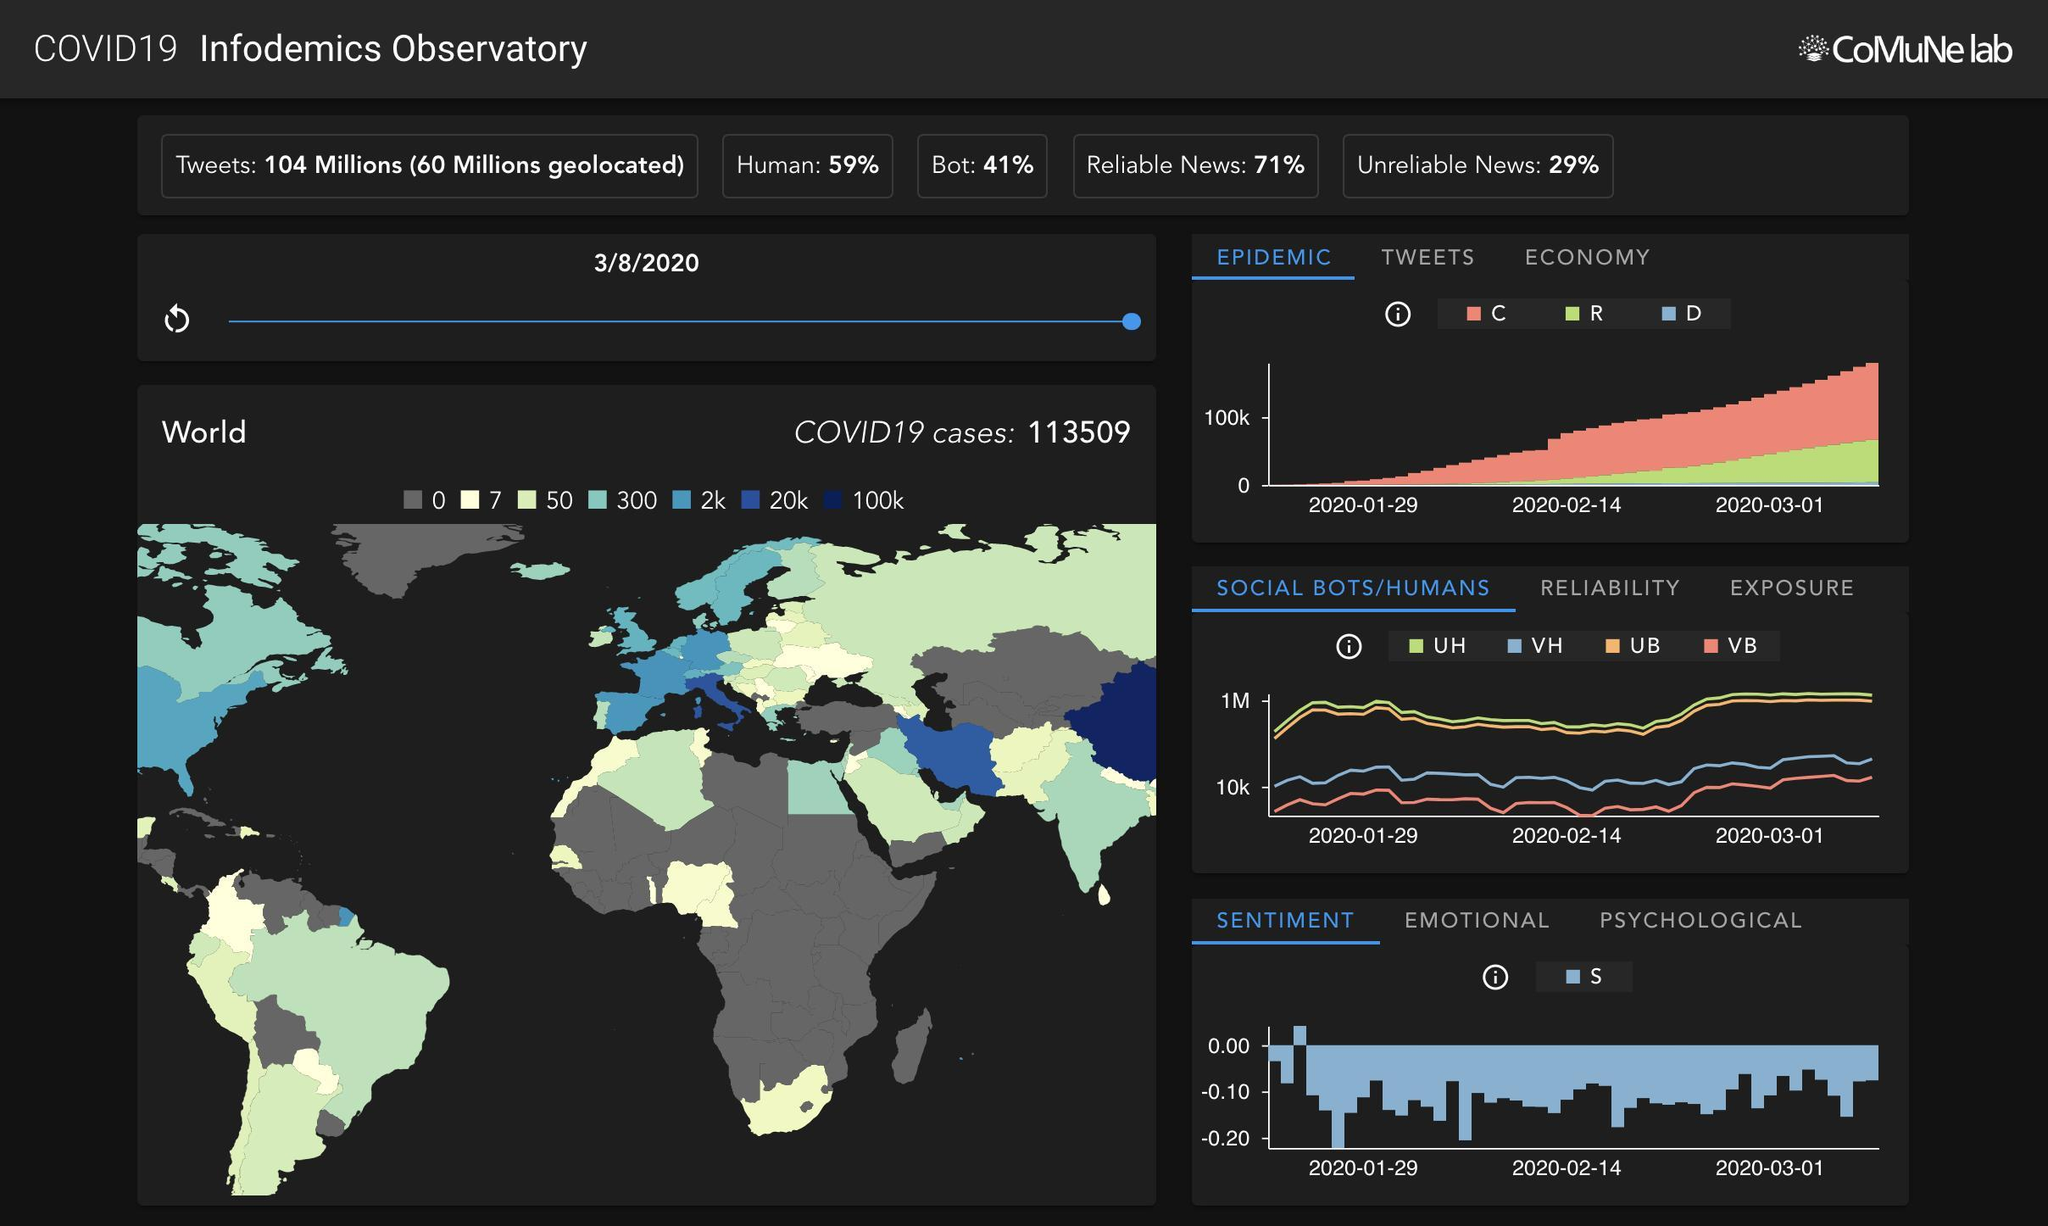Which country has crossed the 100K mark, China or India
Answer the question with a short phrase. China Most parts of which continent have 0 cases, Africa or Asia Africa 